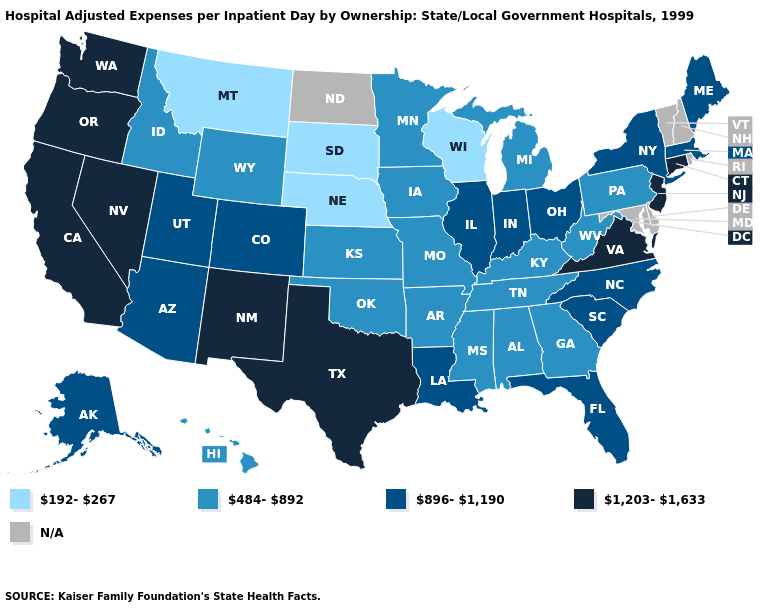Which states hav the highest value in the MidWest?
Quick response, please. Illinois, Indiana, Ohio. Name the states that have a value in the range 192-267?
Answer briefly. Montana, Nebraska, South Dakota, Wisconsin. What is the value of Texas?
Keep it brief. 1,203-1,633. What is the lowest value in states that border South Dakota?
Quick response, please. 192-267. What is the value of Utah?
Be succinct. 896-1,190. What is the lowest value in states that border Louisiana?
Write a very short answer. 484-892. How many symbols are there in the legend?
Short answer required. 5. Does Connecticut have the highest value in the Northeast?
Be succinct. Yes. Among the states that border Georgia , does Alabama have the lowest value?
Keep it brief. Yes. What is the lowest value in states that border Missouri?
Answer briefly. 192-267. What is the value of Pennsylvania?
Quick response, please. 484-892. Name the states that have a value in the range 1,203-1,633?
Write a very short answer. California, Connecticut, Nevada, New Jersey, New Mexico, Oregon, Texas, Virginia, Washington. What is the value of Tennessee?
Give a very brief answer. 484-892. 